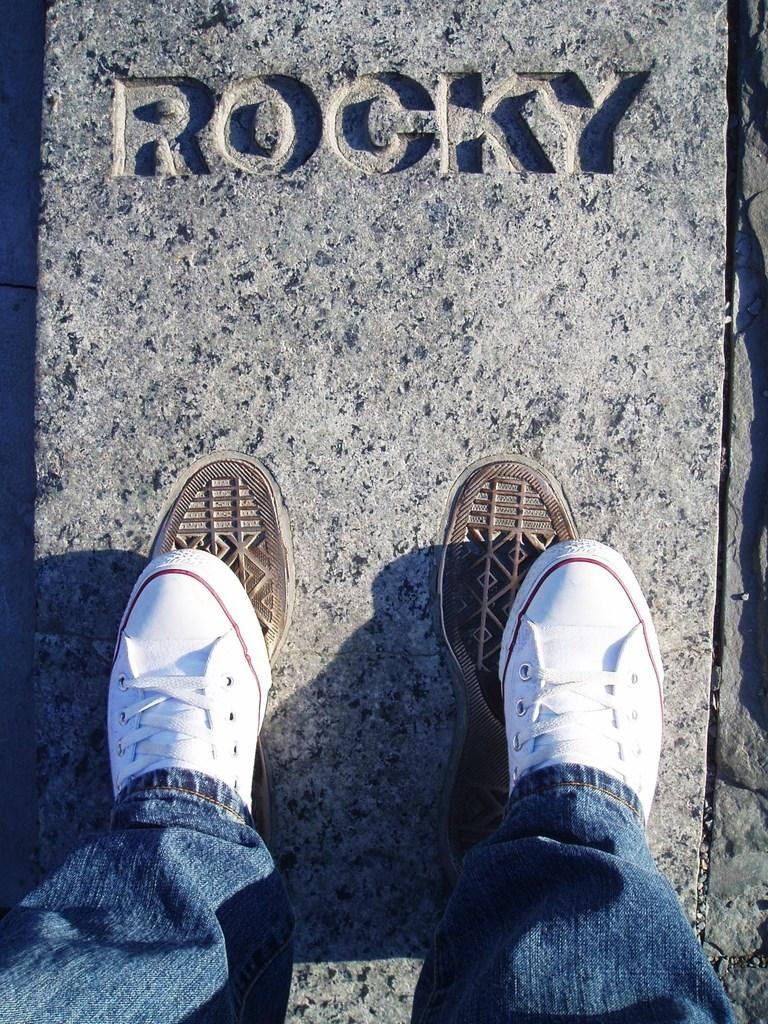What is the main subject of the image? There is a person standing in the image. What is the person standing on? The person is standing on a surface. Is there any text visible in the image? Yes, there is text written on the surface. What type of belief is depicted in the image? There is no belief depicted in the image; it features a person standing on a surface with text written on it. What substance is the person holding in the image? There is no substance visible in the image; it only shows a person standing on a surface with text written on it. 